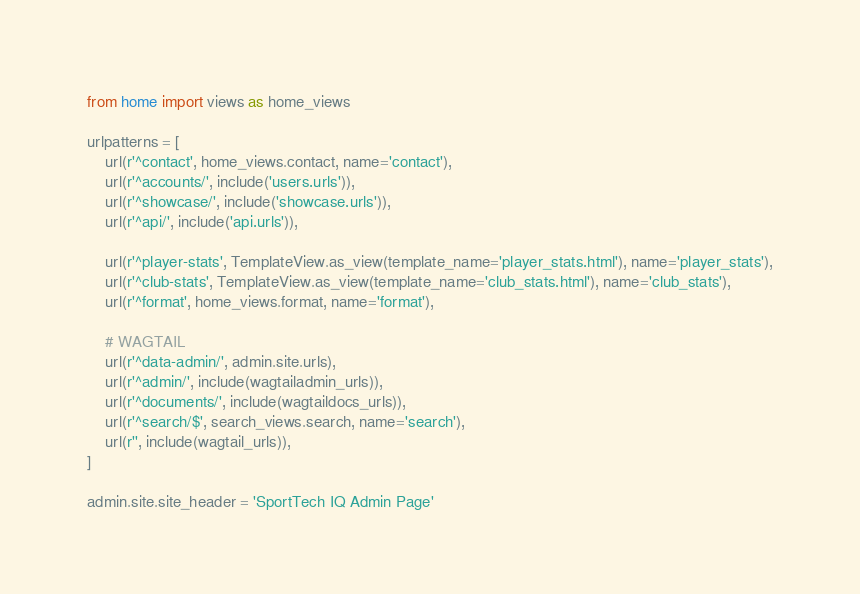<code> <loc_0><loc_0><loc_500><loc_500><_Python_>from home import views as home_views

urlpatterns = [
    url(r'^contact', home_views.contact, name='contact'),
    url(r'^accounts/', include('users.urls')),
    url(r'^showcase/', include('showcase.urls')),
    url(r'^api/', include('api.urls')),

    url(r'^player-stats', TemplateView.as_view(template_name='player_stats.html'), name='player_stats'),
    url(r'^club-stats', TemplateView.as_view(template_name='club_stats.html'), name='club_stats'),
    url(r'^format', home_views.format, name='format'),

    # WAGTAIL
    url(r'^data-admin/', admin.site.urls),
    url(r'^admin/', include(wagtailadmin_urls)),
    url(r'^documents/', include(wagtaildocs_urls)),
    url(r'^search/$', search_views.search, name='search'),
    url(r'', include(wagtail_urls)),
]

admin.site.site_header = 'SportTech IQ Admin Page'
</code> 